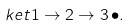Convert formula to latex. <formula><loc_0><loc_0><loc_500><loc_500>\ k e t { 1 \rightarrow 2 \rightarrow 3 \, \bullet } .</formula> 